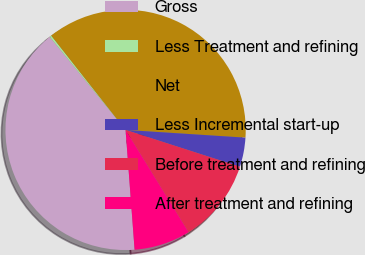Convert chart to OTSL. <chart><loc_0><loc_0><loc_500><loc_500><pie_chart><fcel>Gross<fcel>Less Treatment and refining<fcel>Net<fcel>Less Incremental start-up<fcel>Before treatment and refining<fcel>After treatment and refining<nl><fcel>40.32%<fcel>0.26%<fcel>36.65%<fcel>3.93%<fcel>11.26%<fcel>7.59%<nl></chart> 